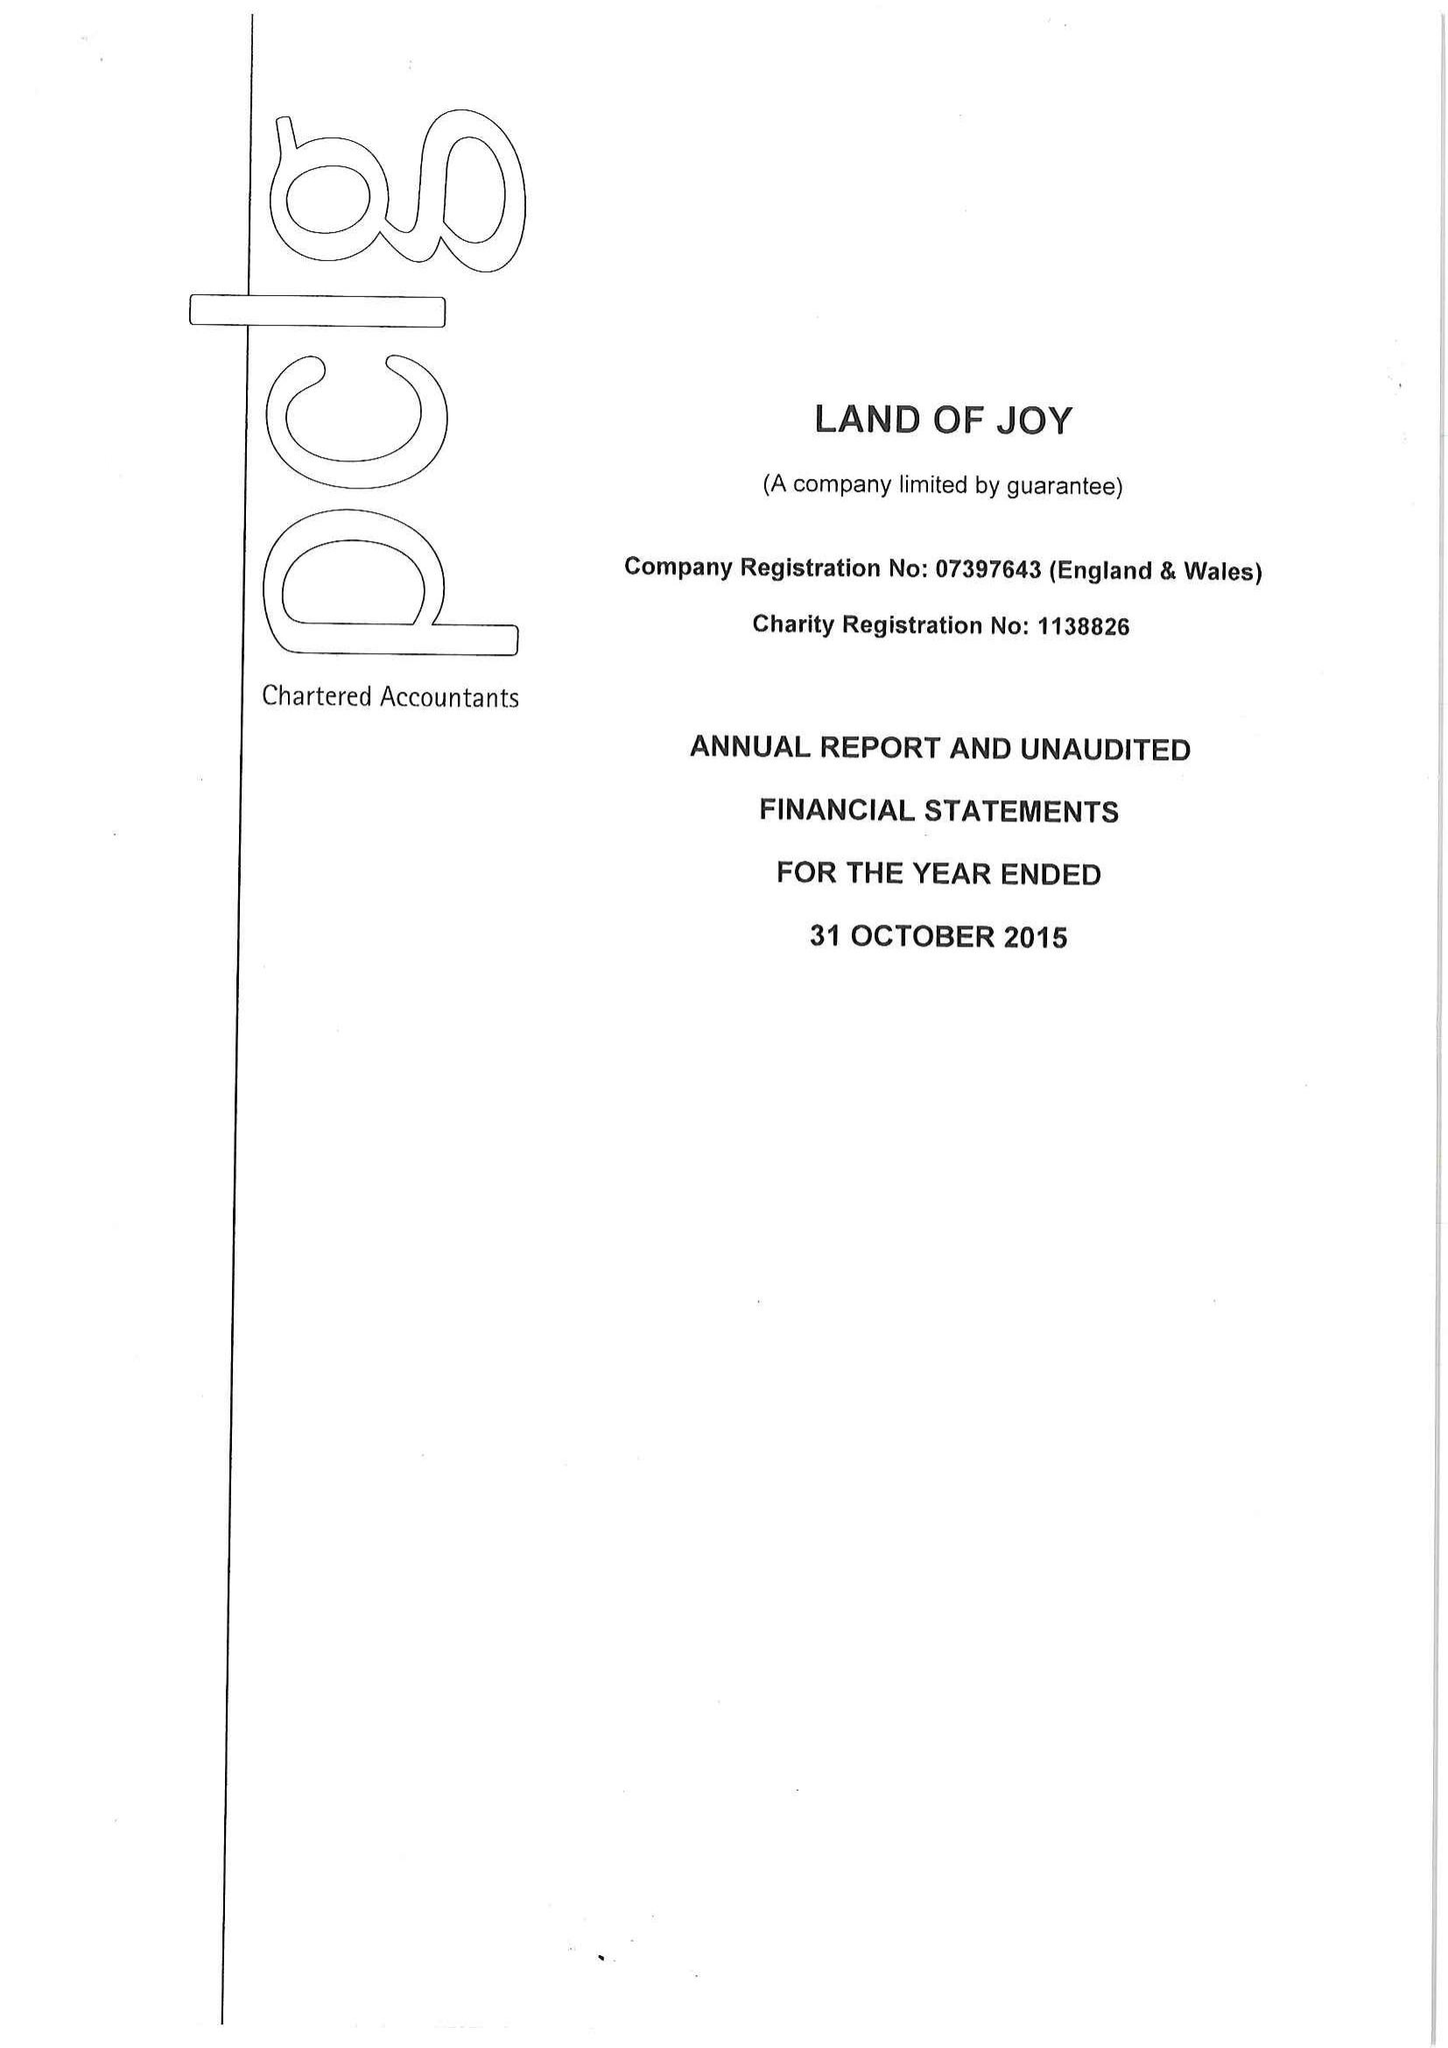What is the value for the address__postcode?
Answer the question using a single word or phrase. NE48 1PP 